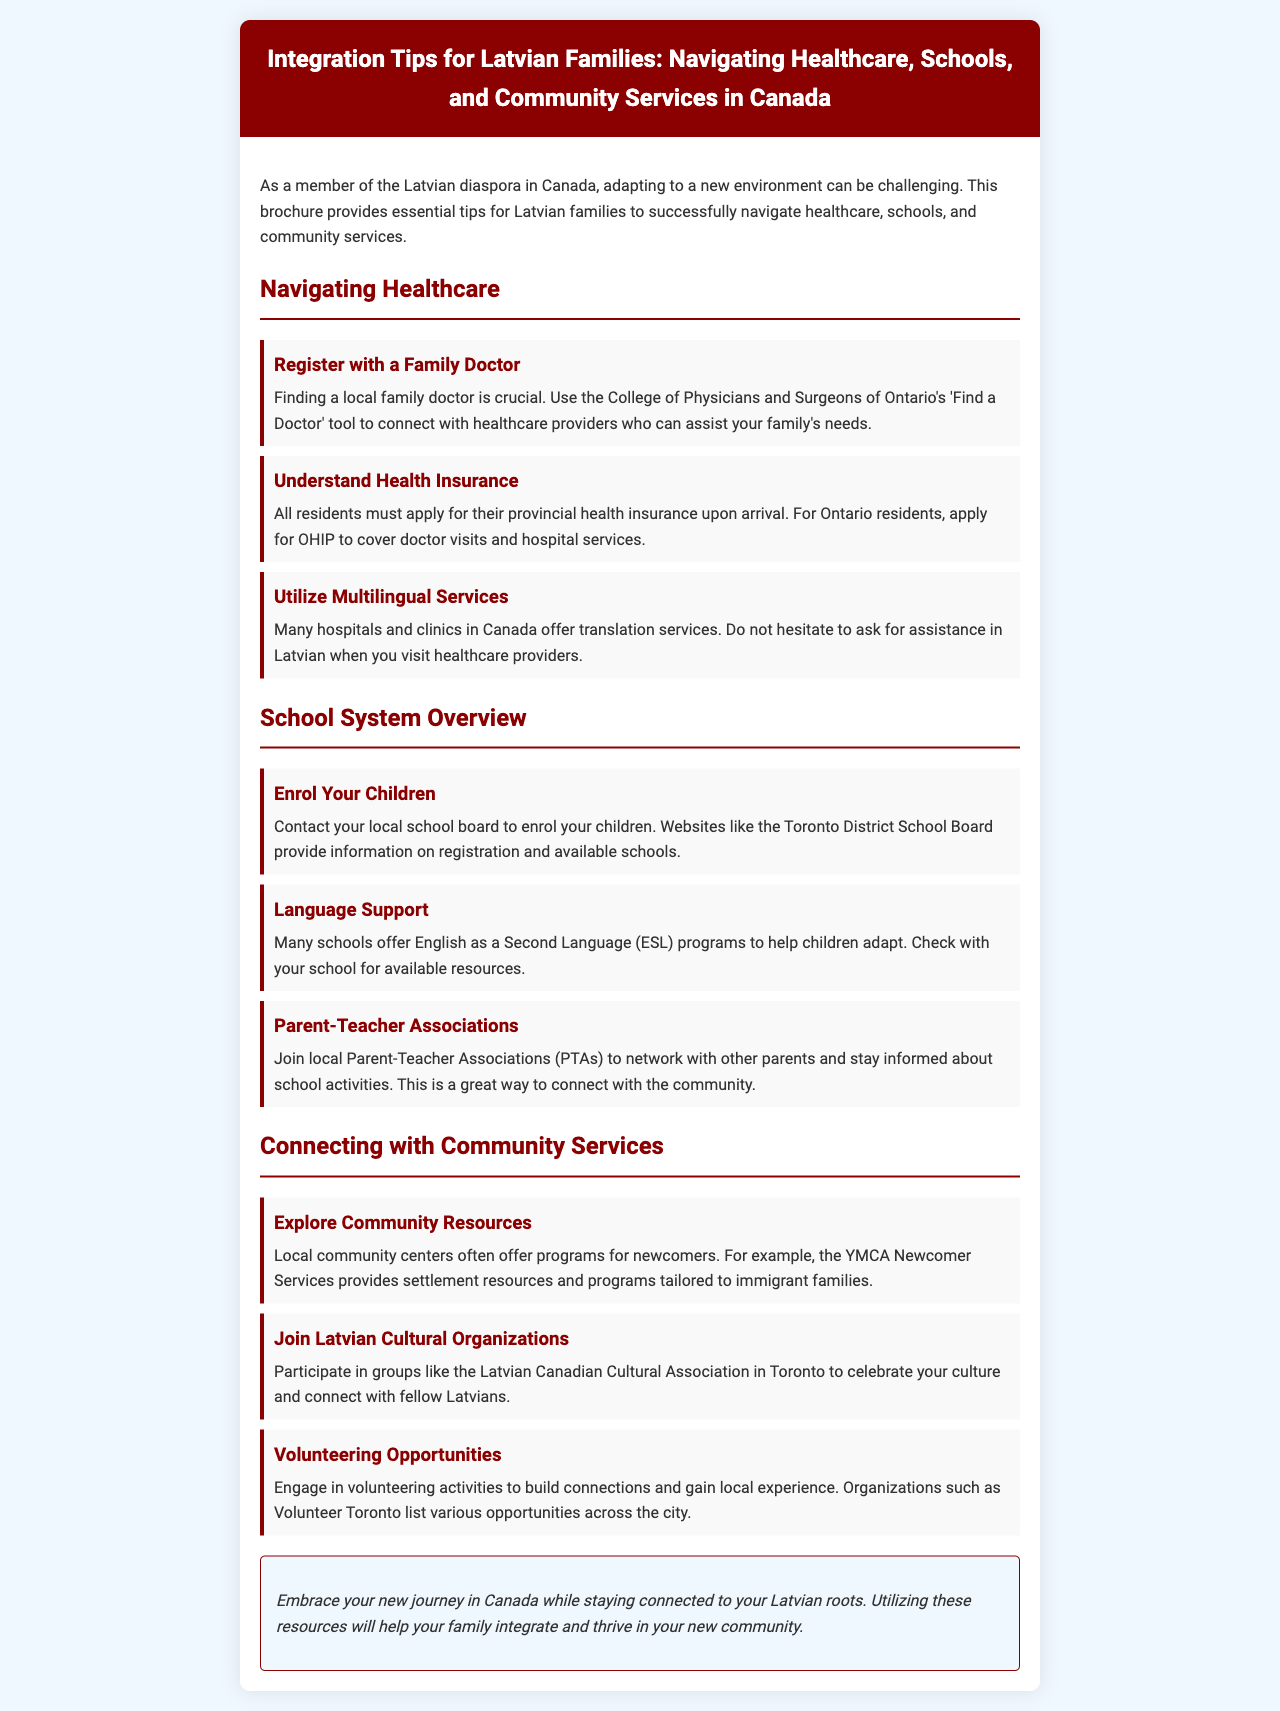What tool can help find a local family doctor? The document mentions using the College of Physicians and Surgeons of Ontario's 'Find a Doctor' tool.
Answer: 'Find a Doctor' tool What must residents apply for upon arrival? The document states that all residents must apply for their provincial health insurance upon arrival.
Answer: provincial health insurance Which program helps children adapt to English? The brochure refers to English as a Second Language (ESL) programs.
Answer: ESL programs What community center program is mentioned for newcomers? The document highlights YMCA Newcomer Services as a program for newcomers.
Answer: YMCA Newcomer Services What can families join to connect with other Latvian families? The brochure suggests joining the Latvian Canadian Cultural Association in Toronto.
Answer: Latvian Canadian Cultural Association How can parents stay informed about school activities? The document advises joining local Parent-Teacher Associations (PTAs) to keep updated.
Answer: Parent-Teacher Associations (PTAs) What is a suggested activity to build connections? Engaging in volunteering activities is recommended in the brochure for building connections.
Answer: volunteering activities Which document type does this content belong to? The structure and content suggest this is an informational brochure.
Answer: brochure 